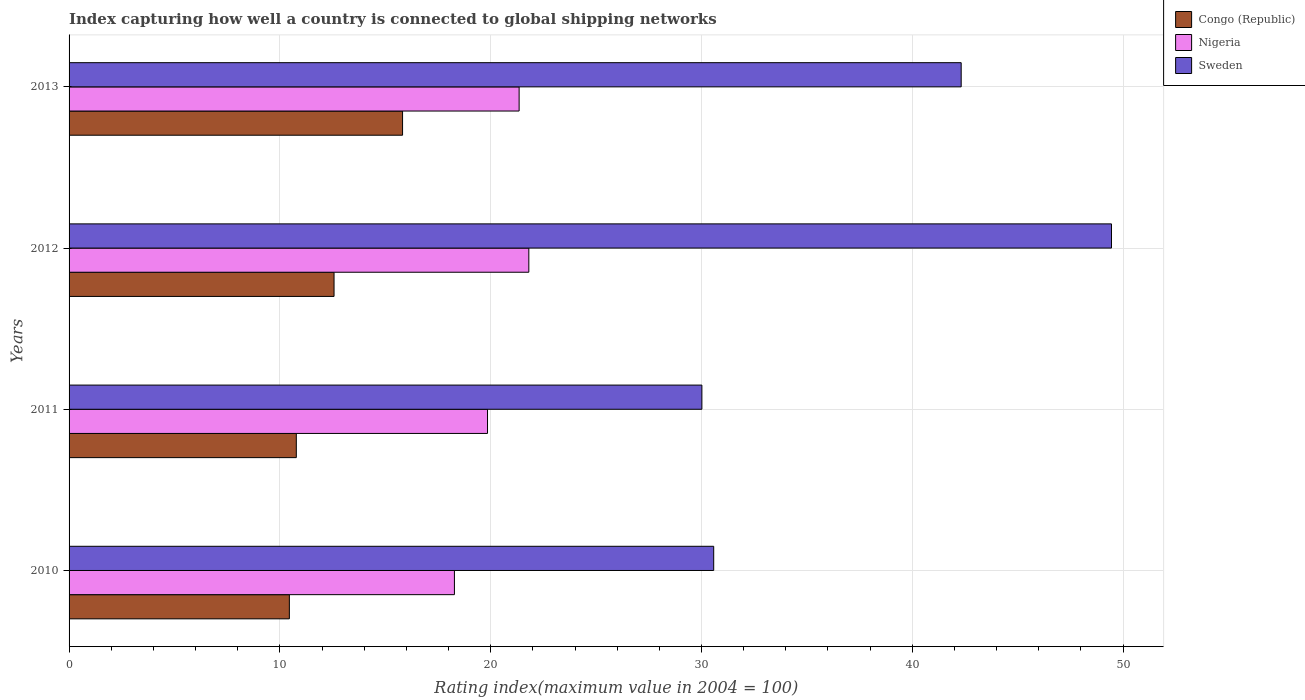How many groups of bars are there?
Offer a terse response. 4. Are the number of bars on each tick of the Y-axis equal?
Ensure brevity in your answer.  Yes. What is the label of the 3rd group of bars from the top?
Ensure brevity in your answer.  2011. In how many cases, is the number of bars for a given year not equal to the number of legend labels?
Offer a terse response. 0. What is the rating index in Nigeria in 2011?
Ensure brevity in your answer.  19.85. Across all years, what is the maximum rating index in Nigeria?
Provide a short and direct response. 21.81. Across all years, what is the minimum rating index in Nigeria?
Offer a very short reply. 18.28. In which year was the rating index in Congo (Republic) minimum?
Your answer should be compact. 2010. What is the total rating index in Congo (Republic) in the graph?
Your answer should be very brief. 49.62. What is the difference between the rating index in Sweden in 2010 and that in 2013?
Your response must be concise. -11.74. What is the difference between the rating index in Congo (Republic) in 2010 and the rating index in Sweden in 2012?
Offer a very short reply. -39. What is the average rating index in Nigeria per year?
Ensure brevity in your answer.  20.32. In the year 2013, what is the difference between the rating index in Congo (Republic) and rating index in Sweden?
Ensure brevity in your answer.  -26.5. In how many years, is the rating index in Congo (Republic) greater than 10 ?
Provide a succinct answer. 4. What is the ratio of the rating index in Sweden in 2010 to that in 2011?
Provide a succinct answer. 1.02. Is the difference between the rating index in Congo (Republic) in 2010 and 2011 greater than the difference between the rating index in Sweden in 2010 and 2011?
Make the answer very short. No. What is the difference between the highest and the second highest rating index in Sweden?
Provide a short and direct response. 7.13. What is the difference between the highest and the lowest rating index in Nigeria?
Give a very brief answer. 3.53. In how many years, is the rating index in Congo (Republic) greater than the average rating index in Congo (Republic) taken over all years?
Provide a succinct answer. 2. Is the sum of the rating index in Nigeria in 2010 and 2012 greater than the maximum rating index in Sweden across all years?
Offer a terse response. No. What does the 2nd bar from the top in 2010 represents?
Your answer should be very brief. Nigeria. What does the 1st bar from the bottom in 2010 represents?
Provide a succinct answer. Congo (Republic). Is it the case that in every year, the sum of the rating index in Sweden and rating index in Nigeria is greater than the rating index in Congo (Republic)?
Your answer should be very brief. Yes. Are the values on the major ticks of X-axis written in scientific E-notation?
Ensure brevity in your answer.  No. Does the graph contain any zero values?
Ensure brevity in your answer.  No. Where does the legend appear in the graph?
Your answer should be very brief. Top right. How are the legend labels stacked?
Provide a succinct answer. Vertical. What is the title of the graph?
Keep it short and to the point. Index capturing how well a country is connected to global shipping networks. Does "Tonga" appear as one of the legend labels in the graph?
Offer a terse response. No. What is the label or title of the X-axis?
Your answer should be compact. Rating index(maximum value in 2004 = 100). What is the label or title of the Y-axis?
Offer a terse response. Years. What is the Rating index(maximum value in 2004 = 100) of Congo (Republic) in 2010?
Provide a succinct answer. 10.45. What is the Rating index(maximum value in 2004 = 100) in Nigeria in 2010?
Your response must be concise. 18.28. What is the Rating index(maximum value in 2004 = 100) of Sweden in 2010?
Offer a very short reply. 30.58. What is the Rating index(maximum value in 2004 = 100) in Congo (Republic) in 2011?
Your response must be concise. 10.78. What is the Rating index(maximum value in 2004 = 100) in Nigeria in 2011?
Keep it short and to the point. 19.85. What is the Rating index(maximum value in 2004 = 100) of Sweden in 2011?
Your answer should be compact. 30.02. What is the Rating index(maximum value in 2004 = 100) of Congo (Republic) in 2012?
Provide a short and direct response. 12.57. What is the Rating index(maximum value in 2004 = 100) in Nigeria in 2012?
Your answer should be very brief. 21.81. What is the Rating index(maximum value in 2004 = 100) of Sweden in 2012?
Make the answer very short. 49.45. What is the Rating index(maximum value in 2004 = 100) in Congo (Republic) in 2013?
Provide a short and direct response. 15.82. What is the Rating index(maximum value in 2004 = 100) of Nigeria in 2013?
Your response must be concise. 21.35. What is the Rating index(maximum value in 2004 = 100) of Sweden in 2013?
Provide a succinct answer. 42.32. Across all years, what is the maximum Rating index(maximum value in 2004 = 100) of Congo (Republic)?
Ensure brevity in your answer.  15.82. Across all years, what is the maximum Rating index(maximum value in 2004 = 100) in Nigeria?
Your response must be concise. 21.81. Across all years, what is the maximum Rating index(maximum value in 2004 = 100) of Sweden?
Provide a short and direct response. 49.45. Across all years, what is the minimum Rating index(maximum value in 2004 = 100) of Congo (Republic)?
Your answer should be very brief. 10.45. Across all years, what is the minimum Rating index(maximum value in 2004 = 100) in Nigeria?
Make the answer very short. 18.28. Across all years, what is the minimum Rating index(maximum value in 2004 = 100) in Sweden?
Offer a terse response. 30.02. What is the total Rating index(maximum value in 2004 = 100) in Congo (Republic) in the graph?
Offer a terse response. 49.62. What is the total Rating index(maximum value in 2004 = 100) of Nigeria in the graph?
Provide a succinct answer. 81.29. What is the total Rating index(maximum value in 2004 = 100) in Sweden in the graph?
Make the answer very short. 152.37. What is the difference between the Rating index(maximum value in 2004 = 100) of Congo (Republic) in 2010 and that in 2011?
Offer a terse response. -0.33. What is the difference between the Rating index(maximum value in 2004 = 100) of Nigeria in 2010 and that in 2011?
Your answer should be very brief. -1.57. What is the difference between the Rating index(maximum value in 2004 = 100) of Sweden in 2010 and that in 2011?
Provide a short and direct response. 0.56. What is the difference between the Rating index(maximum value in 2004 = 100) in Congo (Republic) in 2010 and that in 2012?
Keep it short and to the point. -2.12. What is the difference between the Rating index(maximum value in 2004 = 100) in Nigeria in 2010 and that in 2012?
Your response must be concise. -3.53. What is the difference between the Rating index(maximum value in 2004 = 100) in Sweden in 2010 and that in 2012?
Keep it short and to the point. -18.87. What is the difference between the Rating index(maximum value in 2004 = 100) in Congo (Republic) in 2010 and that in 2013?
Ensure brevity in your answer.  -5.37. What is the difference between the Rating index(maximum value in 2004 = 100) in Nigeria in 2010 and that in 2013?
Offer a very short reply. -3.07. What is the difference between the Rating index(maximum value in 2004 = 100) of Sweden in 2010 and that in 2013?
Make the answer very short. -11.74. What is the difference between the Rating index(maximum value in 2004 = 100) of Congo (Republic) in 2011 and that in 2012?
Make the answer very short. -1.79. What is the difference between the Rating index(maximum value in 2004 = 100) of Nigeria in 2011 and that in 2012?
Your response must be concise. -1.96. What is the difference between the Rating index(maximum value in 2004 = 100) of Sweden in 2011 and that in 2012?
Offer a terse response. -19.43. What is the difference between the Rating index(maximum value in 2004 = 100) in Congo (Republic) in 2011 and that in 2013?
Give a very brief answer. -5.04. What is the difference between the Rating index(maximum value in 2004 = 100) in Nigeria in 2011 and that in 2013?
Your answer should be very brief. -1.5. What is the difference between the Rating index(maximum value in 2004 = 100) of Congo (Republic) in 2012 and that in 2013?
Make the answer very short. -3.25. What is the difference between the Rating index(maximum value in 2004 = 100) of Nigeria in 2012 and that in 2013?
Your answer should be very brief. 0.46. What is the difference between the Rating index(maximum value in 2004 = 100) in Sweden in 2012 and that in 2013?
Make the answer very short. 7.13. What is the difference between the Rating index(maximum value in 2004 = 100) in Congo (Republic) in 2010 and the Rating index(maximum value in 2004 = 100) in Nigeria in 2011?
Provide a short and direct response. -9.4. What is the difference between the Rating index(maximum value in 2004 = 100) in Congo (Republic) in 2010 and the Rating index(maximum value in 2004 = 100) in Sweden in 2011?
Your answer should be compact. -19.57. What is the difference between the Rating index(maximum value in 2004 = 100) in Nigeria in 2010 and the Rating index(maximum value in 2004 = 100) in Sweden in 2011?
Offer a very short reply. -11.74. What is the difference between the Rating index(maximum value in 2004 = 100) in Congo (Republic) in 2010 and the Rating index(maximum value in 2004 = 100) in Nigeria in 2012?
Offer a very short reply. -11.36. What is the difference between the Rating index(maximum value in 2004 = 100) of Congo (Republic) in 2010 and the Rating index(maximum value in 2004 = 100) of Sweden in 2012?
Make the answer very short. -39. What is the difference between the Rating index(maximum value in 2004 = 100) in Nigeria in 2010 and the Rating index(maximum value in 2004 = 100) in Sweden in 2012?
Provide a short and direct response. -31.17. What is the difference between the Rating index(maximum value in 2004 = 100) of Congo (Republic) in 2010 and the Rating index(maximum value in 2004 = 100) of Sweden in 2013?
Provide a succinct answer. -31.87. What is the difference between the Rating index(maximum value in 2004 = 100) of Nigeria in 2010 and the Rating index(maximum value in 2004 = 100) of Sweden in 2013?
Ensure brevity in your answer.  -24.04. What is the difference between the Rating index(maximum value in 2004 = 100) in Congo (Republic) in 2011 and the Rating index(maximum value in 2004 = 100) in Nigeria in 2012?
Offer a very short reply. -11.03. What is the difference between the Rating index(maximum value in 2004 = 100) in Congo (Republic) in 2011 and the Rating index(maximum value in 2004 = 100) in Sweden in 2012?
Give a very brief answer. -38.67. What is the difference between the Rating index(maximum value in 2004 = 100) of Nigeria in 2011 and the Rating index(maximum value in 2004 = 100) of Sweden in 2012?
Ensure brevity in your answer.  -29.6. What is the difference between the Rating index(maximum value in 2004 = 100) of Congo (Republic) in 2011 and the Rating index(maximum value in 2004 = 100) of Nigeria in 2013?
Ensure brevity in your answer.  -10.57. What is the difference between the Rating index(maximum value in 2004 = 100) in Congo (Republic) in 2011 and the Rating index(maximum value in 2004 = 100) in Sweden in 2013?
Give a very brief answer. -31.54. What is the difference between the Rating index(maximum value in 2004 = 100) of Nigeria in 2011 and the Rating index(maximum value in 2004 = 100) of Sweden in 2013?
Offer a very short reply. -22.47. What is the difference between the Rating index(maximum value in 2004 = 100) in Congo (Republic) in 2012 and the Rating index(maximum value in 2004 = 100) in Nigeria in 2013?
Your answer should be very brief. -8.78. What is the difference between the Rating index(maximum value in 2004 = 100) of Congo (Republic) in 2012 and the Rating index(maximum value in 2004 = 100) of Sweden in 2013?
Give a very brief answer. -29.75. What is the difference between the Rating index(maximum value in 2004 = 100) in Nigeria in 2012 and the Rating index(maximum value in 2004 = 100) in Sweden in 2013?
Your answer should be compact. -20.51. What is the average Rating index(maximum value in 2004 = 100) of Congo (Republic) per year?
Your answer should be compact. 12.4. What is the average Rating index(maximum value in 2004 = 100) of Nigeria per year?
Your answer should be compact. 20.32. What is the average Rating index(maximum value in 2004 = 100) of Sweden per year?
Your response must be concise. 38.09. In the year 2010, what is the difference between the Rating index(maximum value in 2004 = 100) in Congo (Republic) and Rating index(maximum value in 2004 = 100) in Nigeria?
Provide a succinct answer. -7.83. In the year 2010, what is the difference between the Rating index(maximum value in 2004 = 100) in Congo (Republic) and Rating index(maximum value in 2004 = 100) in Sweden?
Provide a short and direct response. -20.13. In the year 2010, what is the difference between the Rating index(maximum value in 2004 = 100) in Nigeria and Rating index(maximum value in 2004 = 100) in Sweden?
Provide a succinct answer. -12.3. In the year 2011, what is the difference between the Rating index(maximum value in 2004 = 100) of Congo (Republic) and Rating index(maximum value in 2004 = 100) of Nigeria?
Your response must be concise. -9.07. In the year 2011, what is the difference between the Rating index(maximum value in 2004 = 100) of Congo (Republic) and Rating index(maximum value in 2004 = 100) of Sweden?
Provide a short and direct response. -19.24. In the year 2011, what is the difference between the Rating index(maximum value in 2004 = 100) in Nigeria and Rating index(maximum value in 2004 = 100) in Sweden?
Ensure brevity in your answer.  -10.17. In the year 2012, what is the difference between the Rating index(maximum value in 2004 = 100) of Congo (Republic) and Rating index(maximum value in 2004 = 100) of Nigeria?
Your answer should be compact. -9.24. In the year 2012, what is the difference between the Rating index(maximum value in 2004 = 100) of Congo (Republic) and Rating index(maximum value in 2004 = 100) of Sweden?
Provide a short and direct response. -36.88. In the year 2012, what is the difference between the Rating index(maximum value in 2004 = 100) of Nigeria and Rating index(maximum value in 2004 = 100) of Sweden?
Make the answer very short. -27.64. In the year 2013, what is the difference between the Rating index(maximum value in 2004 = 100) of Congo (Republic) and Rating index(maximum value in 2004 = 100) of Nigeria?
Make the answer very short. -5.53. In the year 2013, what is the difference between the Rating index(maximum value in 2004 = 100) in Congo (Republic) and Rating index(maximum value in 2004 = 100) in Sweden?
Your answer should be very brief. -26.5. In the year 2013, what is the difference between the Rating index(maximum value in 2004 = 100) in Nigeria and Rating index(maximum value in 2004 = 100) in Sweden?
Keep it short and to the point. -20.97. What is the ratio of the Rating index(maximum value in 2004 = 100) in Congo (Republic) in 2010 to that in 2011?
Your answer should be very brief. 0.97. What is the ratio of the Rating index(maximum value in 2004 = 100) in Nigeria in 2010 to that in 2011?
Offer a very short reply. 0.92. What is the ratio of the Rating index(maximum value in 2004 = 100) in Sweden in 2010 to that in 2011?
Offer a very short reply. 1.02. What is the ratio of the Rating index(maximum value in 2004 = 100) of Congo (Republic) in 2010 to that in 2012?
Your answer should be compact. 0.83. What is the ratio of the Rating index(maximum value in 2004 = 100) in Nigeria in 2010 to that in 2012?
Your answer should be compact. 0.84. What is the ratio of the Rating index(maximum value in 2004 = 100) of Sweden in 2010 to that in 2012?
Your answer should be compact. 0.62. What is the ratio of the Rating index(maximum value in 2004 = 100) in Congo (Republic) in 2010 to that in 2013?
Offer a very short reply. 0.66. What is the ratio of the Rating index(maximum value in 2004 = 100) of Nigeria in 2010 to that in 2013?
Offer a very short reply. 0.86. What is the ratio of the Rating index(maximum value in 2004 = 100) in Sweden in 2010 to that in 2013?
Make the answer very short. 0.72. What is the ratio of the Rating index(maximum value in 2004 = 100) of Congo (Republic) in 2011 to that in 2012?
Keep it short and to the point. 0.86. What is the ratio of the Rating index(maximum value in 2004 = 100) in Nigeria in 2011 to that in 2012?
Offer a very short reply. 0.91. What is the ratio of the Rating index(maximum value in 2004 = 100) in Sweden in 2011 to that in 2012?
Provide a succinct answer. 0.61. What is the ratio of the Rating index(maximum value in 2004 = 100) of Congo (Republic) in 2011 to that in 2013?
Give a very brief answer. 0.68. What is the ratio of the Rating index(maximum value in 2004 = 100) of Nigeria in 2011 to that in 2013?
Ensure brevity in your answer.  0.93. What is the ratio of the Rating index(maximum value in 2004 = 100) of Sweden in 2011 to that in 2013?
Keep it short and to the point. 0.71. What is the ratio of the Rating index(maximum value in 2004 = 100) of Congo (Republic) in 2012 to that in 2013?
Keep it short and to the point. 0.79. What is the ratio of the Rating index(maximum value in 2004 = 100) in Nigeria in 2012 to that in 2013?
Your answer should be very brief. 1.02. What is the ratio of the Rating index(maximum value in 2004 = 100) of Sweden in 2012 to that in 2013?
Offer a terse response. 1.17. What is the difference between the highest and the second highest Rating index(maximum value in 2004 = 100) of Congo (Republic)?
Your response must be concise. 3.25. What is the difference between the highest and the second highest Rating index(maximum value in 2004 = 100) of Nigeria?
Provide a short and direct response. 0.46. What is the difference between the highest and the second highest Rating index(maximum value in 2004 = 100) of Sweden?
Give a very brief answer. 7.13. What is the difference between the highest and the lowest Rating index(maximum value in 2004 = 100) in Congo (Republic)?
Provide a succinct answer. 5.37. What is the difference between the highest and the lowest Rating index(maximum value in 2004 = 100) of Nigeria?
Provide a short and direct response. 3.53. What is the difference between the highest and the lowest Rating index(maximum value in 2004 = 100) of Sweden?
Offer a very short reply. 19.43. 